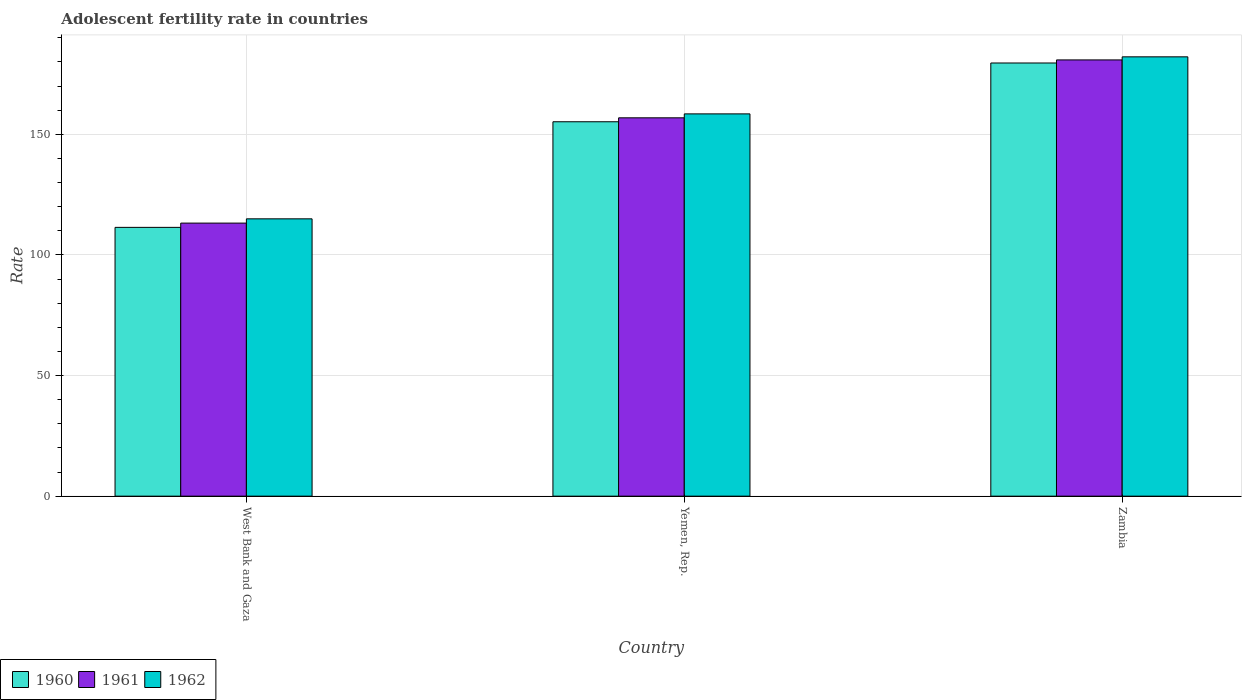How many different coloured bars are there?
Make the answer very short. 3. Are the number of bars per tick equal to the number of legend labels?
Make the answer very short. Yes. Are the number of bars on each tick of the X-axis equal?
Provide a succinct answer. Yes. How many bars are there on the 3rd tick from the right?
Ensure brevity in your answer.  3. What is the label of the 3rd group of bars from the left?
Your answer should be compact. Zambia. What is the adolescent fertility rate in 1961 in West Bank and Gaza?
Give a very brief answer. 113.2. Across all countries, what is the maximum adolescent fertility rate in 1961?
Your answer should be compact. 180.85. Across all countries, what is the minimum adolescent fertility rate in 1960?
Provide a short and direct response. 111.43. In which country was the adolescent fertility rate in 1962 maximum?
Your answer should be very brief. Zambia. In which country was the adolescent fertility rate in 1960 minimum?
Your answer should be very brief. West Bank and Gaza. What is the total adolescent fertility rate in 1962 in the graph?
Offer a very short reply. 455.57. What is the difference between the adolescent fertility rate in 1962 in Yemen, Rep. and that in Zambia?
Ensure brevity in your answer.  -23.65. What is the difference between the adolescent fertility rate in 1962 in Yemen, Rep. and the adolescent fertility rate in 1960 in Zambia?
Provide a short and direct response. -21.1. What is the average adolescent fertility rate in 1961 per country?
Keep it short and to the point. 150.3. What is the difference between the adolescent fertility rate of/in 1961 and adolescent fertility rate of/in 1962 in West Bank and Gaza?
Keep it short and to the point. -1.77. In how many countries, is the adolescent fertility rate in 1962 greater than 150?
Ensure brevity in your answer.  2. What is the ratio of the adolescent fertility rate in 1960 in West Bank and Gaza to that in Zambia?
Make the answer very short. 0.62. Is the adolescent fertility rate in 1960 in West Bank and Gaza less than that in Yemen, Rep.?
Offer a terse response. Yes. Is the difference between the adolescent fertility rate in 1961 in Yemen, Rep. and Zambia greater than the difference between the adolescent fertility rate in 1962 in Yemen, Rep. and Zambia?
Provide a succinct answer. No. What is the difference between the highest and the second highest adolescent fertility rate in 1960?
Provide a succinct answer. 24.36. What is the difference between the highest and the lowest adolescent fertility rate in 1961?
Your answer should be very brief. 67.65. Is the sum of the adolescent fertility rate in 1960 in Yemen, Rep. and Zambia greater than the maximum adolescent fertility rate in 1962 across all countries?
Provide a short and direct response. Yes. What does the 3rd bar from the right in Yemen, Rep. represents?
Give a very brief answer. 1960. Are all the bars in the graph horizontal?
Give a very brief answer. No. How many countries are there in the graph?
Ensure brevity in your answer.  3. What is the difference between two consecutive major ticks on the Y-axis?
Provide a short and direct response. 50. Does the graph contain any zero values?
Ensure brevity in your answer.  No. How are the legend labels stacked?
Offer a terse response. Horizontal. What is the title of the graph?
Give a very brief answer. Adolescent fertility rate in countries. Does "2002" appear as one of the legend labels in the graph?
Make the answer very short. No. What is the label or title of the X-axis?
Ensure brevity in your answer.  Country. What is the label or title of the Y-axis?
Provide a short and direct response. Rate. What is the Rate in 1960 in West Bank and Gaza?
Make the answer very short. 111.43. What is the Rate in 1961 in West Bank and Gaza?
Your answer should be compact. 113.2. What is the Rate in 1962 in West Bank and Gaza?
Provide a succinct answer. 114.97. What is the Rate in 1960 in Yemen, Rep.?
Offer a very short reply. 155.21. What is the Rate of 1961 in Yemen, Rep.?
Your answer should be compact. 156.85. What is the Rate of 1962 in Yemen, Rep.?
Keep it short and to the point. 158.48. What is the Rate of 1960 in Zambia?
Offer a terse response. 179.58. What is the Rate in 1961 in Zambia?
Your answer should be compact. 180.85. What is the Rate of 1962 in Zambia?
Ensure brevity in your answer.  182.12. Across all countries, what is the maximum Rate of 1960?
Keep it short and to the point. 179.58. Across all countries, what is the maximum Rate in 1961?
Ensure brevity in your answer.  180.85. Across all countries, what is the maximum Rate of 1962?
Your answer should be compact. 182.12. Across all countries, what is the minimum Rate of 1960?
Your answer should be very brief. 111.43. Across all countries, what is the minimum Rate of 1961?
Keep it short and to the point. 113.2. Across all countries, what is the minimum Rate of 1962?
Keep it short and to the point. 114.97. What is the total Rate in 1960 in the graph?
Your answer should be compact. 446.22. What is the total Rate in 1961 in the graph?
Your answer should be compact. 450.89. What is the total Rate of 1962 in the graph?
Offer a very short reply. 455.57. What is the difference between the Rate of 1960 in West Bank and Gaza and that in Yemen, Rep.?
Give a very brief answer. -43.78. What is the difference between the Rate in 1961 in West Bank and Gaza and that in Yemen, Rep.?
Keep it short and to the point. -43.65. What is the difference between the Rate of 1962 in West Bank and Gaza and that in Yemen, Rep.?
Your answer should be very brief. -43.51. What is the difference between the Rate in 1960 in West Bank and Gaza and that in Zambia?
Ensure brevity in your answer.  -68.15. What is the difference between the Rate in 1961 in West Bank and Gaza and that in Zambia?
Make the answer very short. -67.65. What is the difference between the Rate in 1962 in West Bank and Gaza and that in Zambia?
Give a very brief answer. -67.16. What is the difference between the Rate of 1960 in Yemen, Rep. and that in Zambia?
Keep it short and to the point. -24.36. What is the difference between the Rate in 1961 in Yemen, Rep. and that in Zambia?
Offer a terse response. -24. What is the difference between the Rate of 1962 in Yemen, Rep. and that in Zambia?
Your response must be concise. -23.65. What is the difference between the Rate in 1960 in West Bank and Gaza and the Rate in 1961 in Yemen, Rep.?
Keep it short and to the point. -45.41. What is the difference between the Rate of 1960 in West Bank and Gaza and the Rate of 1962 in Yemen, Rep.?
Your answer should be very brief. -47.05. What is the difference between the Rate in 1961 in West Bank and Gaza and the Rate in 1962 in Yemen, Rep.?
Your answer should be very brief. -45.28. What is the difference between the Rate of 1960 in West Bank and Gaza and the Rate of 1961 in Zambia?
Offer a very short reply. -69.42. What is the difference between the Rate of 1960 in West Bank and Gaza and the Rate of 1962 in Zambia?
Provide a succinct answer. -70.69. What is the difference between the Rate in 1961 in West Bank and Gaza and the Rate in 1962 in Zambia?
Provide a short and direct response. -68.92. What is the difference between the Rate of 1960 in Yemen, Rep. and the Rate of 1961 in Zambia?
Offer a terse response. -25.64. What is the difference between the Rate in 1960 in Yemen, Rep. and the Rate in 1962 in Zambia?
Offer a terse response. -26.91. What is the difference between the Rate in 1961 in Yemen, Rep. and the Rate in 1962 in Zambia?
Give a very brief answer. -25.28. What is the average Rate of 1960 per country?
Ensure brevity in your answer.  148.74. What is the average Rate in 1961 per country?
Make the answer very short. 150.3. What is the average Rate of 1962 per country?
Keep it short and to the point. 151.86. What is the difference between the Rate in 1960 and Rate in 1961 in West Bank and Gaza?
Provide a short and direct response. -1.77. What is the difference between the Rate of 1960 and Rate of 1962 in West Bank and Gaza?
Offer a very short reply. -3.54. What is the difference between the Rate in 1961 and Rate in 1962 in West Bank and Gaza?
Offer a very short reply. -1.77. What is the difference between the Rate in 1960 and Rate in 1961 in Yemen, Rep.?
Ensure brevity in your answer.  -1.63. What is the difference between the Rate in 1960 and Rate in 1962 in Yemen, Rep.?
Make the answer very short. -3.26. What is the difference between the Rate of 1961 and Rate of 1962 in Yemen, Rep.?
Provide a short and direct response. -1.63. What is the difference between the Rate of 1960 and Rate of 1961 in Zambia?
Provide a short and direct response. -1.27. What is the difference between the Rate of 1960 and Rate of 1962 in Zambia?
Offer a very short reply. -2.55. What is the difference between the Rate of 1961 and Rate of 1962 in Zambia?
Keep it short and to the point. -1.27. What is the ratio of the Rate in 1960 in West Bank and Gaza to that in Yemen, Rep.?
Give a very brief answer. 0.72. What is the ratio of the Rate of 1961 in West Bank and Gaza to that in Yemen, Rep.?
Give a very brief answer. 0.72. What is the ratio of the Rate in 1962 in West Bank and Gaza to that in Yemen, Rep.?
Provide a short and direct response. 0.73. What is the ratio of the Rate in 1960 in West Bank and Gaza to that in Zambia?
Your answer should be very brief. 0.62. What is the ratio of the Rate of 1961 in West Bank and Gaza to that in Zambia?
Your answer should be very brief. 0.63. What is the ratio of the Rate in 1962 in West Bank and Gaza to that in Zambia?
Your answer should be very brief. 0.63. What is the ratio of the Rate of 1960 in Yemen, Rep. to that in Zambia?
Make the answer very short. 0.86. What is the ratio of the Rate in 1961 in Yemen, Rep. to that in Zambia?
Offer a terse response. 0.87. What is the ratio of the Rate in 1962 in Yemen, Rep. to that in Zambia?
Provide a short and direct response. 0.87. What is the difference between the highest and the second highest Rate of 1960?
Give a very brief answer. 24.36. What is the difference between the highest and the second highest Rate of 1961?
Your response must be concise. 24. What is the difference between the highest and the second highest Rate of 1962?
Your response must be concise. 23.65. What is the difference between the highest and the lowest Rate in 1960?
Provide a short and direct response. 68.15. What is the difference between the highest and the lowest Rate of 1961?
Provide a short and direct response. 67.65. What is the difference between the highest and the lowest Rate of 1962?
Your answer should be compact. 67.16. 